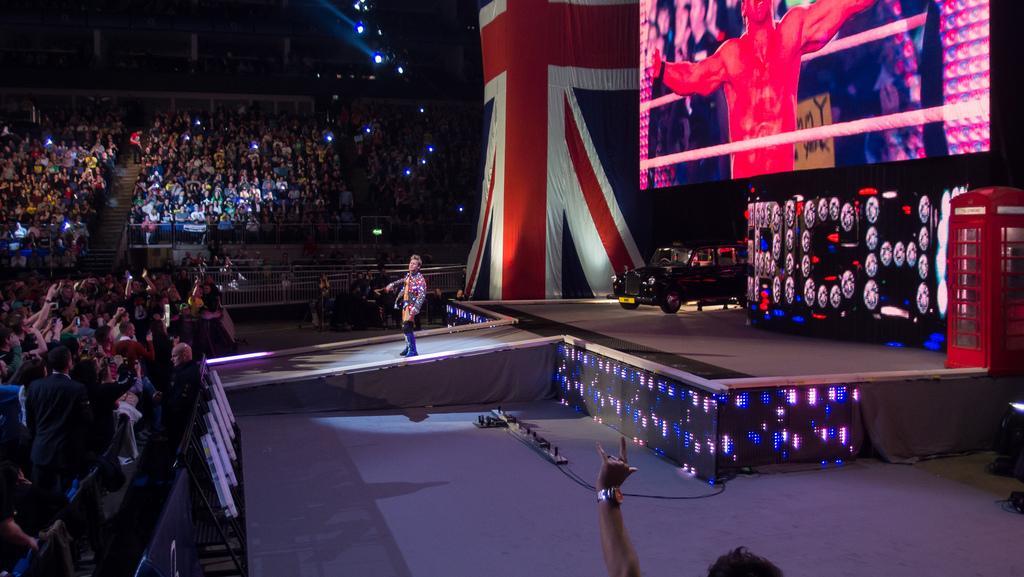In one or two sentences, can you explain what this image depicts? On the left side of the picture there are barricades and audience. In the foreground there is a person's hand. In the center of the picture there is a stage, on the stage there are car and a person standing. At the top right there is a television screen and flag. In the background there are people, chairs and lights. 